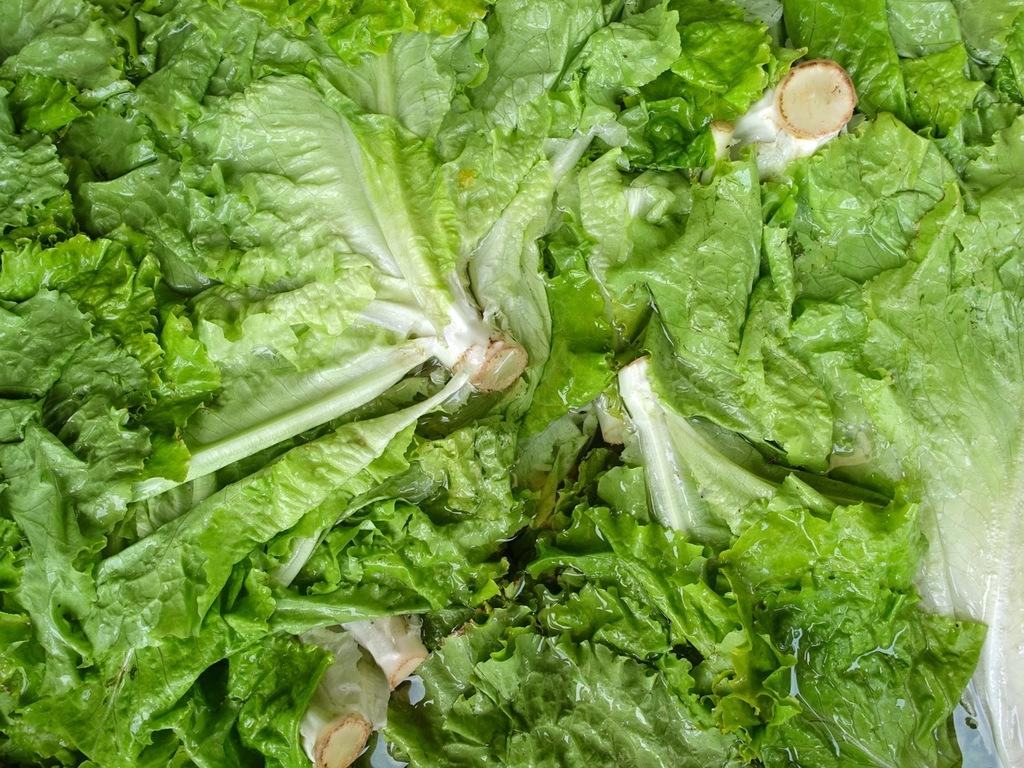What type of vegetable is present in the image? There is a bunch of lettuce in the image. Can you describe the appearance of the lettuce? The lettuce appears to be a bunch of green leaves. What might the lettuce be used for? The lettuce might be used for salads, sandwiches, or other dishes. What story is being told by the lettuce in the image? The lettuce in the image is not telling a story; it is simply a bunch of lettuce. 